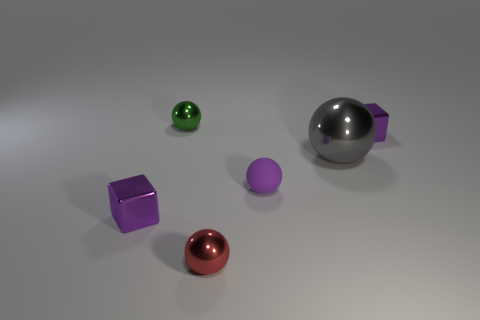Add 2 small purple rubber objects. How many objects exist? 8 Subtract all tiny purple spheres. How many spheres are left? 3 Subtract all spheres. How many objects are left? 2 Subtract all purple spheres. How many yellow cubes are left? 0 Subtract all small red objects. Subtract all small metal blocks. How many objects are left? 3 Add 2 gray spheres. How many gray spheres are left? 3 Add 1 matte balls. How many matte balls exist? 2 Subtract all green spheres. How many spheres are left? 3 Subtract 0 yellow spheres. How many objects are left? 6 Subtract 1 cubes. How many cubes are left? 1 